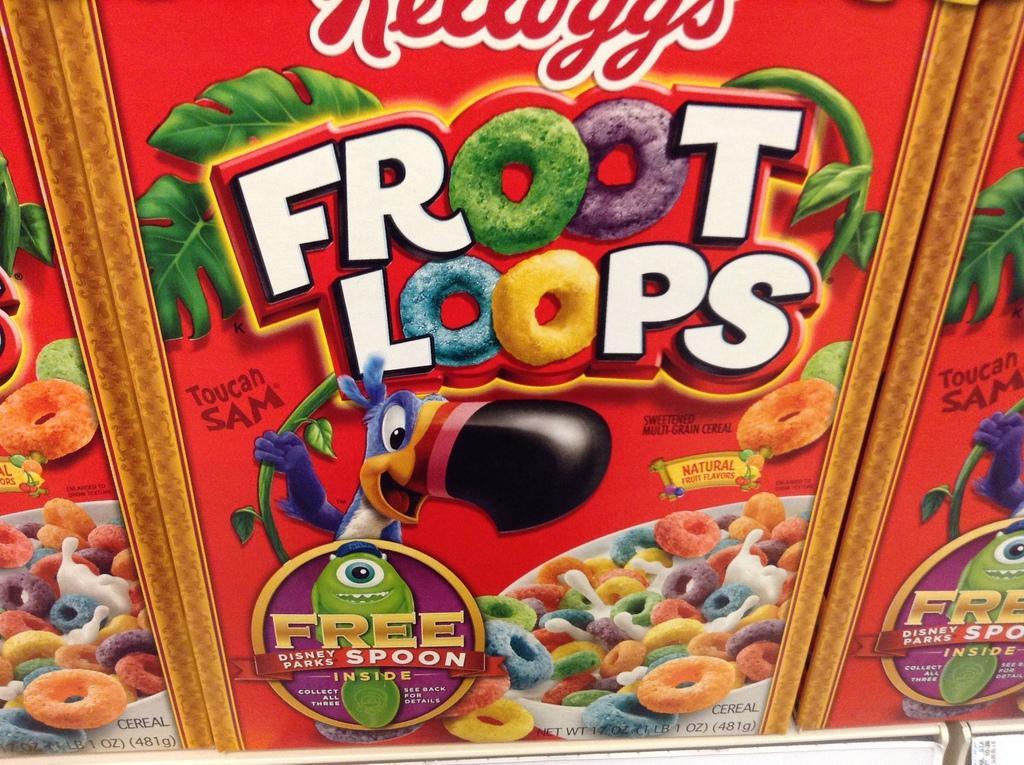Can you describe this image briefly? This image consists of a box. On that there are ''Froot loops'' written on it. There are some cartoons on that. 